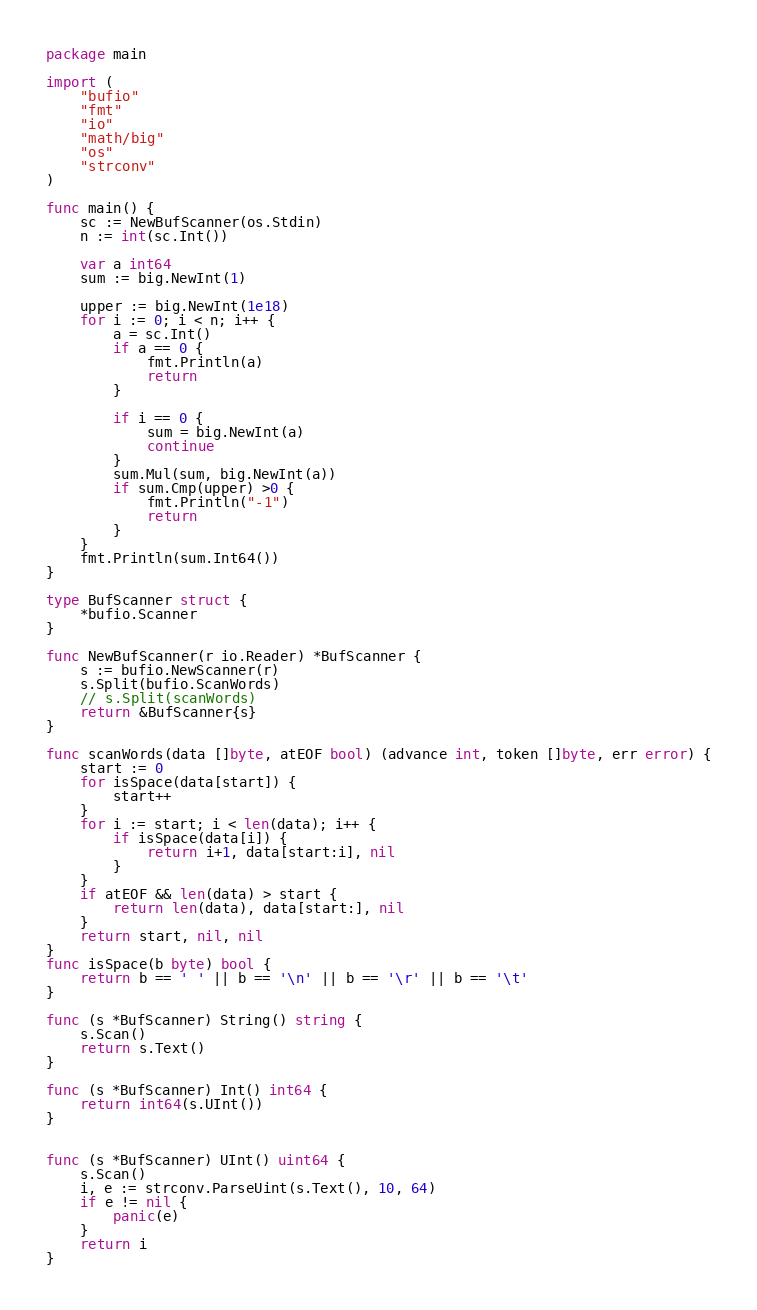Convert code to text. <code><loc_0><loc_0><loc_500><loc_500><_Go_>package main

import (
	"bufio"
	"fmt"
	"io"
	"math/big"
	"os"
	"strconv"
)

func main() {
	sc := NewBufScanner(os.Stdin)
	n := int(sc.Int())

	var a int64
	sum := big.NewInt(1)

	upper := big.NewInt(1e18)
	for i := 0; i < n; i++ {
		a = sc.Int()
		if a == 0 {
			fmt.Println(a)
			return
		}

		if i == 0 {
			sum = big.NewInt(a)
			continue
		}
		sum.Mul(sum, big.NewInt(a))
		if sum.Cmp(upper) >0 {
			fmt.Println("-1")
			return
		}
	}
	fmt.Println(sum.Int64())
}

type BufScanner struct {
	*bufio.Scanner
}

func NewBufScanner(r io.Reader) *BufScanner {
	s := bufio.NewScanner(r)
	s.Split(bufio.ScanWords)
	// s.Split(scanWords)
	return &BufScanner{s}
}

func scanWords(data []byte, atEOF bool) (advance int, token []byte, err error) {
	start := 0
	for isSpace(data[start]) {
		start++
	}
	for i := start; i < len(data); i++ {
		if isSpace(data[i]) {
			return i+1, data[start:i], nil
		}
	}
	if atEOF && len(data) > start {
		return len(data), data[start:], nil
	}
	return start, nil, nil
}
func isSpace(b byte) bool {
	return b == ' ' || b == '\n' || b == '\r' || b == '\t'
}

func (s *BufScanner) String() string {
	s.Scan()
	return s.Text()
}

func (s *BufScanner) Int() int64 {
	return int64(s.UInt())
}


func (s *BufScanner) UInt() uint64 {
	s.Scan()
	i, e := strconv.ParseUint(s.Text(), 10, 64)
	if e != nil {
		panic(e)
	}
	return i
}
</code> 